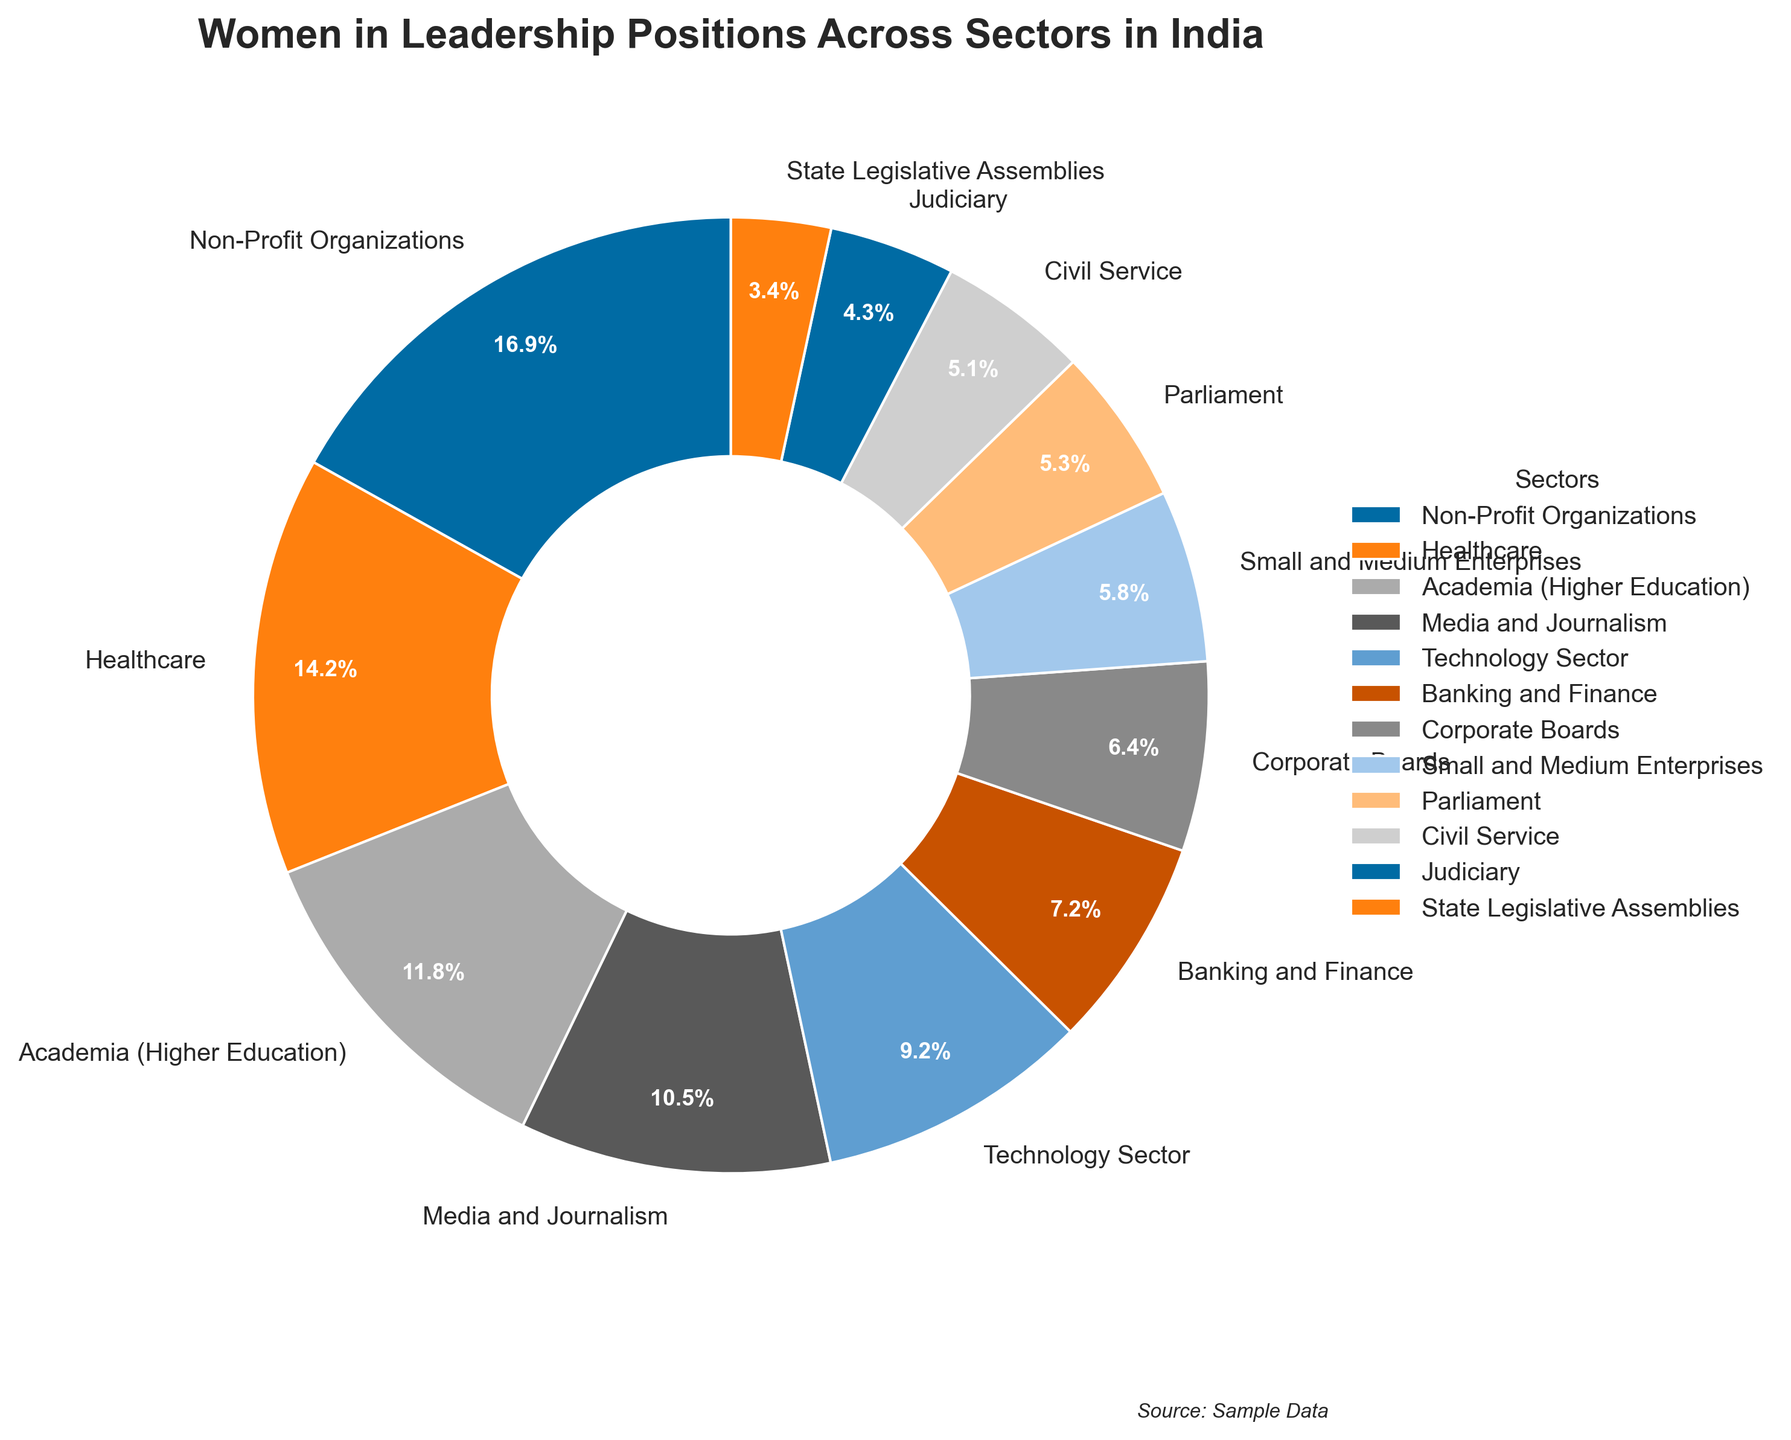Which sector has the highest percentage of women in leadership positions? To determine the sector with the highest percentage, we look for the largest value in the pie chart. The sector labeled "Non-Profit Organizations" has the highest, with 45.6%.
Answer: Non-Profit Organizations Which sector has the lowest percentage of women in leadership positions? To find the sector with the lowest percentage, we look for the smallest value on the pie chart. The sector labeled "State Legislative Assemblies" has the lowest, with 9.1%.
Answer: State Legislative Assemblies What is the combined percentage of women in leadership positions in Parliament and the Judiciary? To get the combined percentage, we add the values for the two sectors: Parliament (14.4%) and Judiciary (11.5%). Therefore, 14.4 + 11.5 = 25.9%.
Answer: 25.9% Which sector has a greater percentage of women in leadership positions, Banking and Finance or the Technology Sector? By comparing the values on the pie chart, we see that Banking and Finance has 19.3% and the Technology Sector has 24.9%. 24.9% > 19.3%, so the Technology Sector has a higher percentage.
Answer: Technology Sector How much more percentage of women in leadership positions does Healthcare have compared to Corporate Boards? To find this, we subtract the percentage of Corporate Boards (17.3%) from Healthcare (38.2%). Therefore, 38.2 - 17.3 = 20.9%.
Answer: 20.9% What is the total percentage of women in leadership positions in Corporate Boards, Civil Service, and Academia (Higher Education)? To find the total percentage, we add the values for these sectors: Corporate Boards (17.3%), Civil Service (13.7%), and Academia (31.8%). So, 17.3 + 13.7 + 31.8 = 62.8%.
Answer: 62.8% Which sectors have a percentage of women in leadership positions greater than 30%? We identify sectors from the pie chart with percentages above 30%. These are: Academia (Higher Education) with 31.8% and Healthcare at 38.2%, and Non-Profit Organizations at 45.6%.
Answer: Academia, Healthcare, Non-Profit Organizations What percentage of women in leadership positions is in the Media and Journalism sector? From the pie chart, Media and Journalism has a sector labeled with 28.4% for women in leadership roles.
Answer: 28.4% Is the percentage of women in leadership positions in the Civil Service greater than in the Judiciary? Comparing Civil Service (13.7%) with the Judiciary (11.5%) from the pie chart, 13.7% > 11.5%, so the percentage is greater for the Civil Service.
Answer: Yes, it is greater 